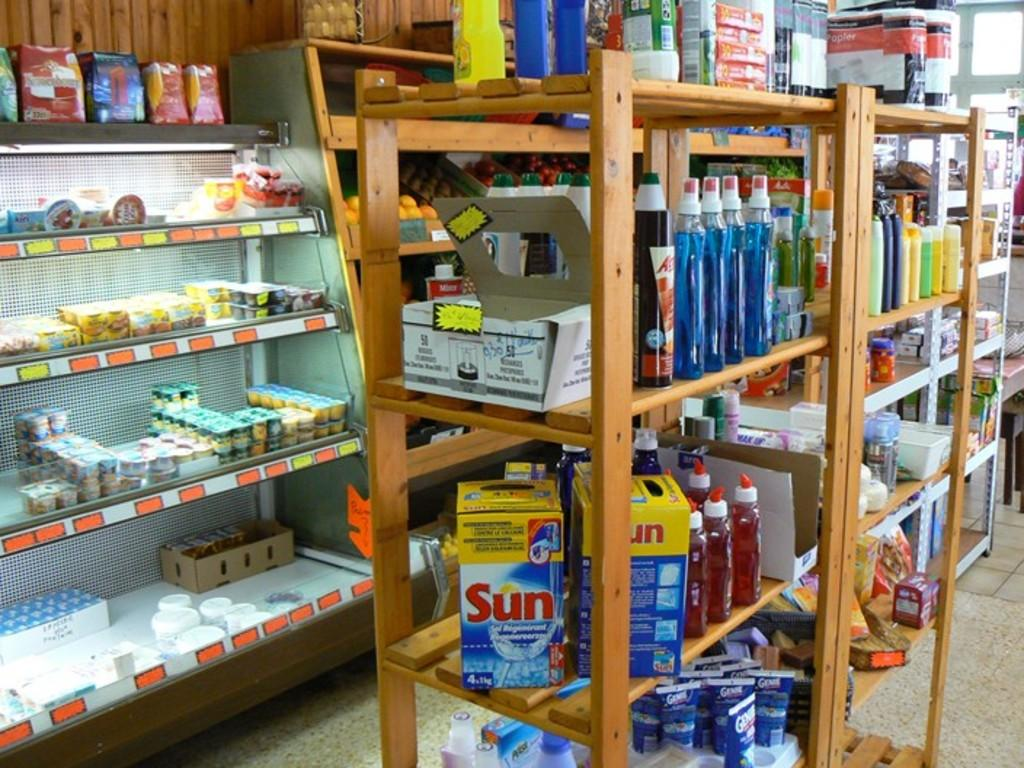<image>
Present a compact description of the photo's key features. Shelves in a store with a Sun box on the middle one 